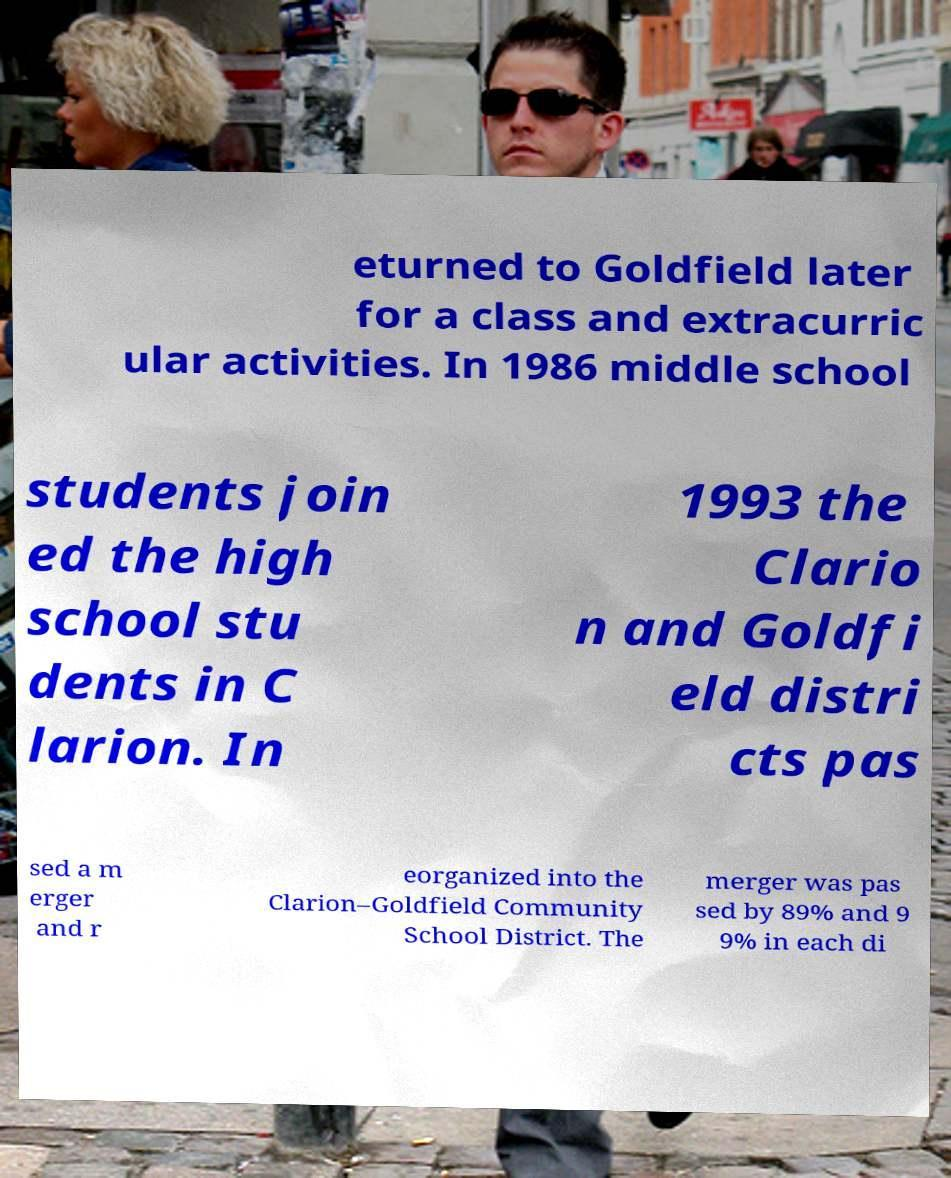There's text embedded in this image that I need extracted. Can you transcribe it verbatim? eturned to Goldfield later for a class and extracurric ular activities. In 1986 middle school students join ed the high school stu dents in C larion. In 1993 the Clario n and Goldfi eld distri cts pas sed a m erger and r eorganized into the Clarion–Goldfield Community School District. The merger was pas sed by 89% and 9 9% in each di 